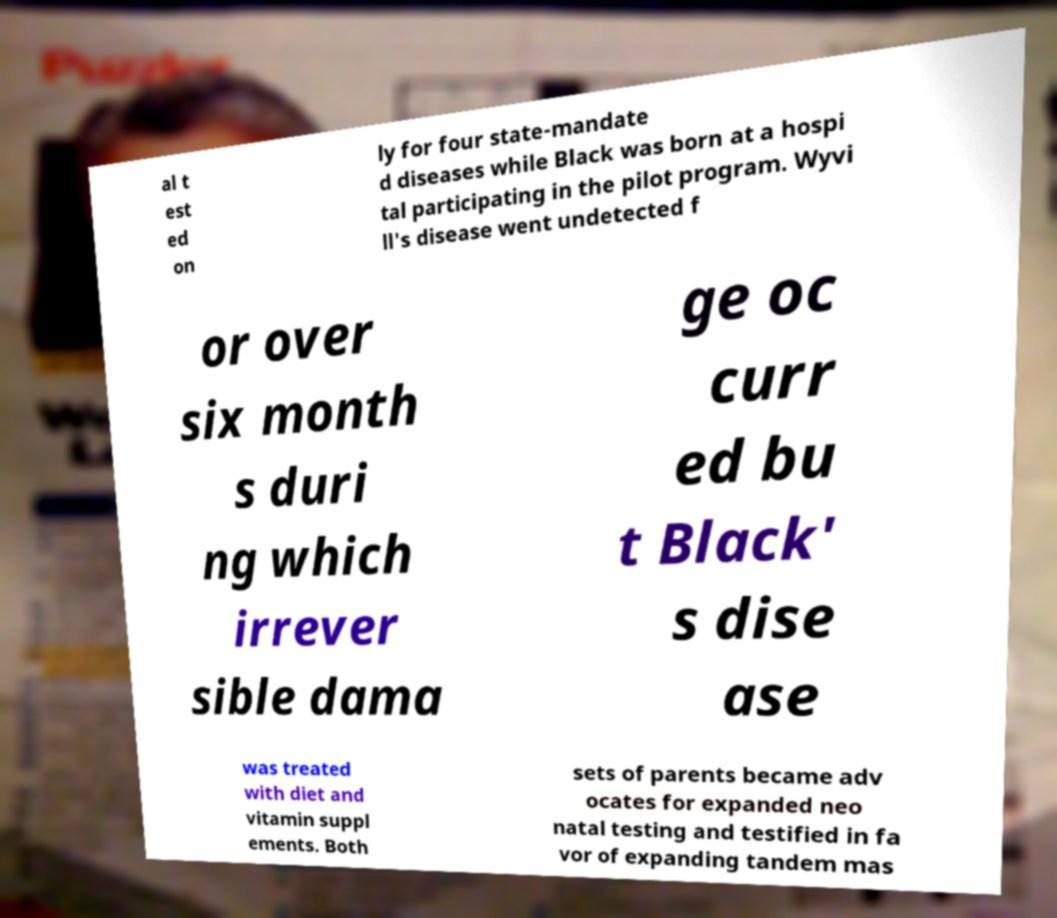I need the written content from this picture converted into text. Can you do that? al t est ed on ly for four state-mandate d diseases while Black was born at a hospi tal participating in the pilot program. Wyvi ll's disease went undetected f or over six month s duri ng which irrever sible dama ge oc curr ed bu t Black' s dise ase was treated with diet and vitamin suppl ements. Both sets of parents became adv ocates for expanded neo natal testing and testified in fa vor of expanding tandem mas 